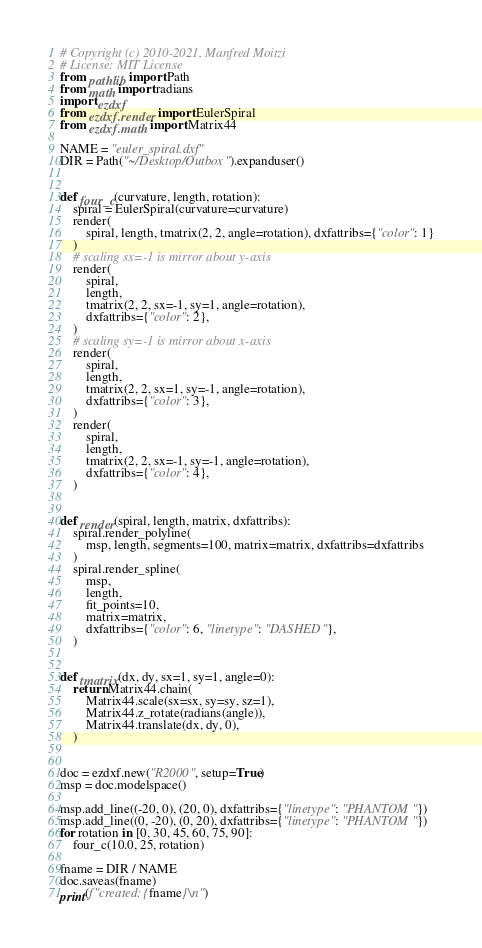<code> <loc_0><loc_0><loc_500><loc_500><_Python_># Copyright (c) 2010-2021, Manfred Moitzi
# License: MIT License
from pathlib import Path
from math import radians
import ezdxf
from ezdxf.render import EulerSpiral
from ezdxf.math import Matrix44

NAME = "euler_spiral.dxf"
DIR = Path("~/Desktop/Outbox").expanduser()


def four_c(curvature, length, rotation):
    spiral = EulerSpiral(curvature=curvature)
    render(
        spiral, length, tmatrix(2, 2, angle=rotation), dxfattribs={"color": 1}
    )
    # scaling sx=-1 is mirror about y-axis
    render(
        spiral,
        length,
        tmatrix(2, 2, sx=-1, sy=1, angle=rotation),
        dxfattribs={"color": 2},
    )
    # scaling sy=-1 is mirror about x-axis
    render(
        spiral,
        length,
        tmatrix(2, 2, sx=1, sy=-1, angle=rotation),
        dxfattribs={"color": 3},
    )
    render(
        spiral,
        length,
        tmatrix(2, 2, sx=-1, sy=-1, angle=rotation),
        dxfattribs={"color": 4},
    )


def render(spiral, length, matrix, dxfattribs):
    spiral.render_polyline(
        msp, length, segments=100, matrix=matrix, dxfattribs=dxfattribs
    )
    spiral.render_spline(
        msp,
        length,
        fit_points=10,
        matrix=matrix,
        dxfattribs={"color": 6, "linetype": "DASHED"},
    )


def tmatrix(dx, dy, sx=1, sy=1, angle=0):
    return Matrix44.chain(
        Matrix44.scale(sx=sx, sy=sy, sz=1),
        Matrix44.z_rotate(radians(angle)),
        Matrix44.translate(dx, dy, 0),
    )


doc = ezdxf.new("R2000", setup=True)
msp = doc.modelspace()

msp.add_line((-20, 0), (20, 0), dxfattribs={"linetype": "PHANTOM"})
msp.add_line((0, -20), (0, 20), dxfattribs={"linetype": "PHANTOM"})
for rotation in [0, 30, 45, 60, 75, 90]:
    four_c(10.0, 25, rotation)

fname = DIR / NAME
doc.saveas(fname)
print(f"created: {fname}\n")
</code> 